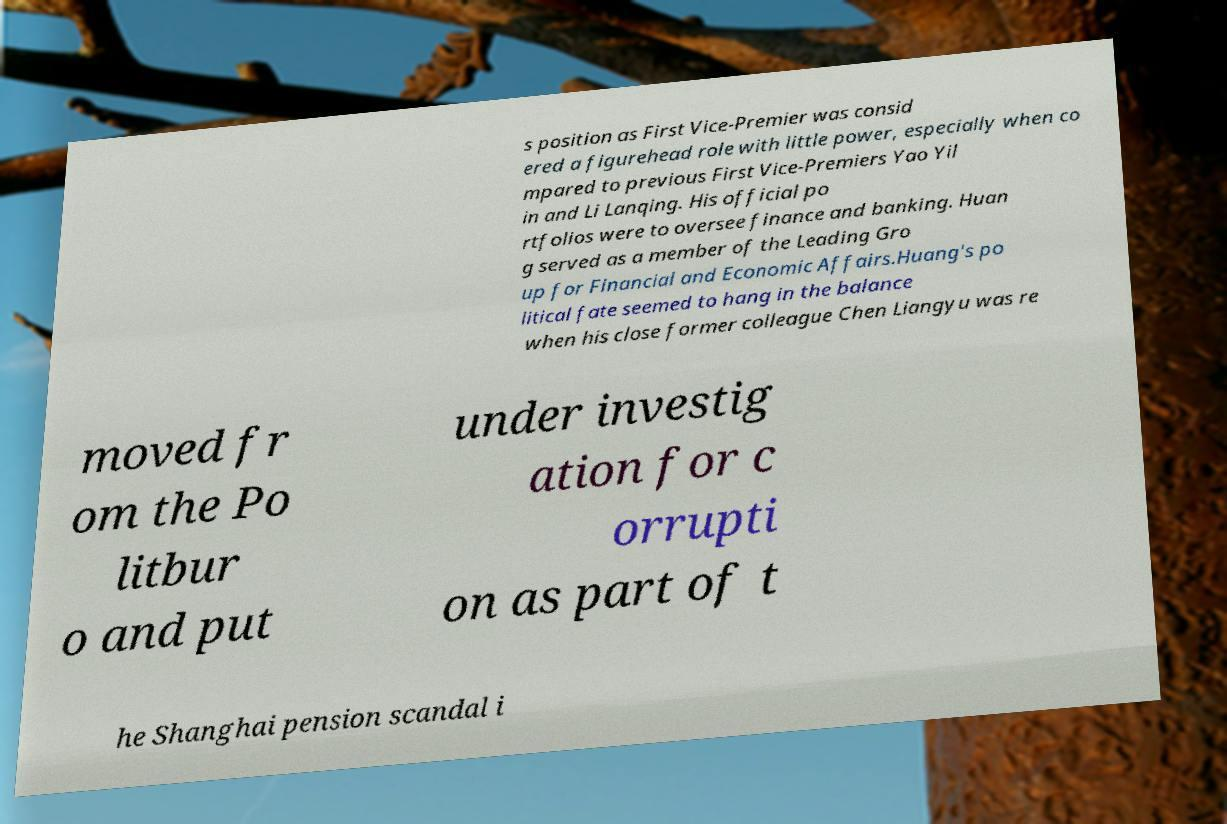Could you extract and type out the text from this image? s position as First Vice-Premier was consid ered a figurehead role with little power, especially when co mpared to previous First Vice-Premiers Yao Yil in and Li Lanqing. His official po rtfolios were to oversee finance and banking. Huan g served as a member of the Leading Gro up for Financial and Economic Affairs.Huang's po litical fate seemed to hang in the balance when his close former colleague Chen Liangyu was re moved fr om the Po litbur o and put under investig ation for c orrupti on as part of t he Shanghai pension scandal i 